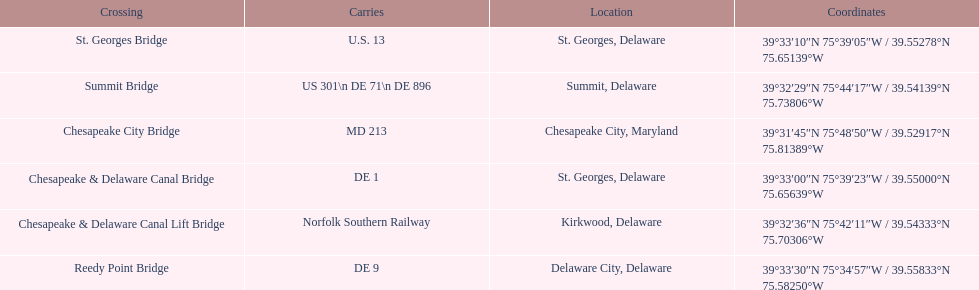Which bridge is in delaware and carries de 9? Reedy Point Bridge. 